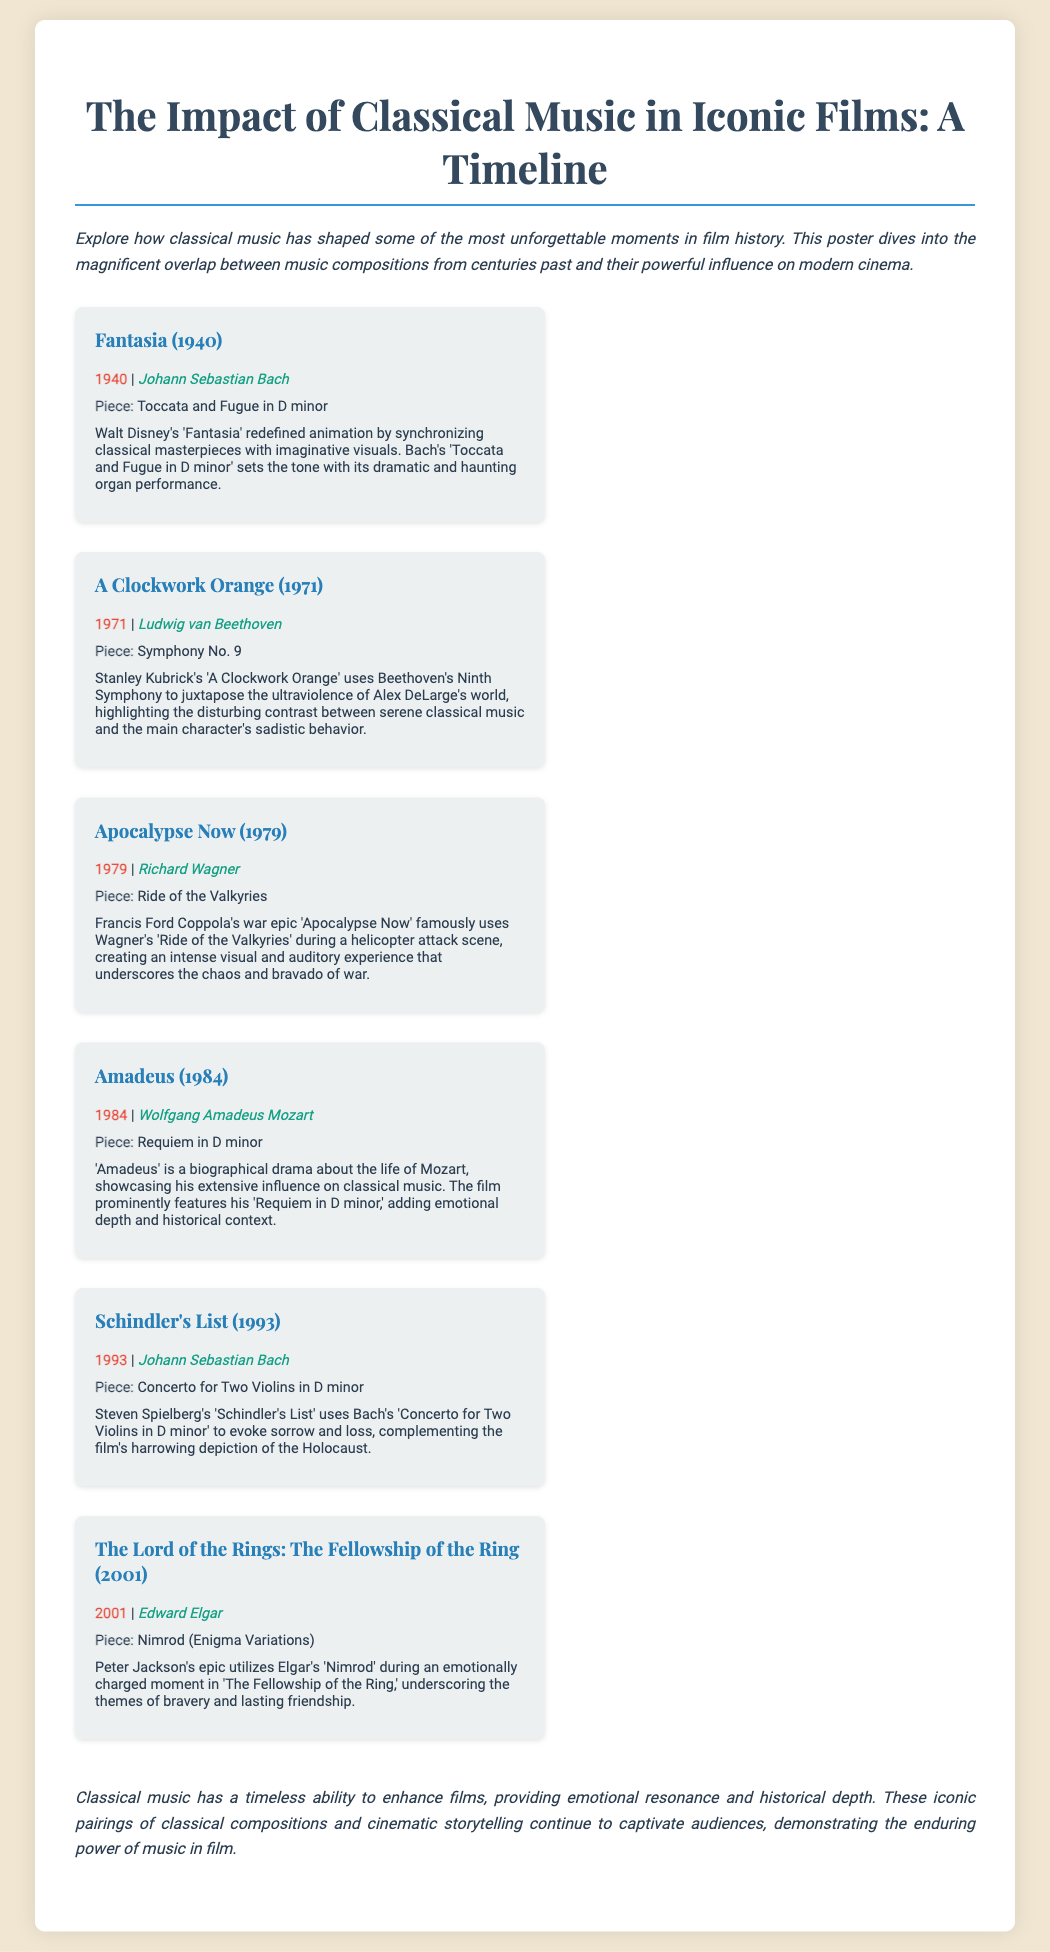What year was "Fantasia" released? The document states that "Fantasia" was released in 1940.
Answer: 1940 Who composed "Symphony No. 9"? The composer of "Symphony No. 9" featured in "A Clockwork Orange" is Ludwig van Beethoven.
Answer: Ludwig van Beethoven What piece is used in "Apocalypse Now"? The document mentions that Richard Wagner's "Ride of the Valkyries" is used in "Apocalypse Now."
Answer: Ride of the Valkyries In which film is Bach's "Concerto for Two Violins in D minor" featured? The document indicates that "Schindler's List" features Bach's "Concerto for Two Violins in D minor."
Answer: Schindler's List What is the main theme highlighted in "The Lord of the Rings: The Fellowship of the Ring"? The document suggests that bravery and lasting friendship are the main themes underscored by Elgar's "Nimrod."
Answer: Bravery and lasting friendship How does classical music enhance films, according to the poster? The conclusion states that classical music provides emotional resonance and historical depth to films.
Answer: Emotional resonance and historical depth What is the historical significance of Mozart's "Requiem in D minor" in "Amadeus"? The film "Amadeus" prominently features "Requiem in D minor" adding emotional depth and historical context.
Answer: Emotional depth and historical context Which film uses Beethoven's music to contrast with violence? The poster notes that "A Clockwork Orange" uses Beethoven's Ninth Symphony to juxtapose violence.
Answer: A Clockwork Orange 